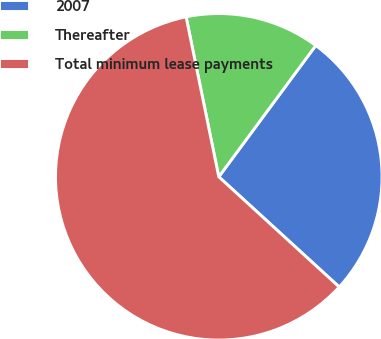Convert chart to OTSL. <chart><loc_0><loc_0><loc_500><loc_500><pie_chart><fcel>2007<fcel>Thereafter<fcel>Total minimum lease payments<nl><fcel>26.67%<fcel>13.33%<fcel>60.0%<nl></chart> 